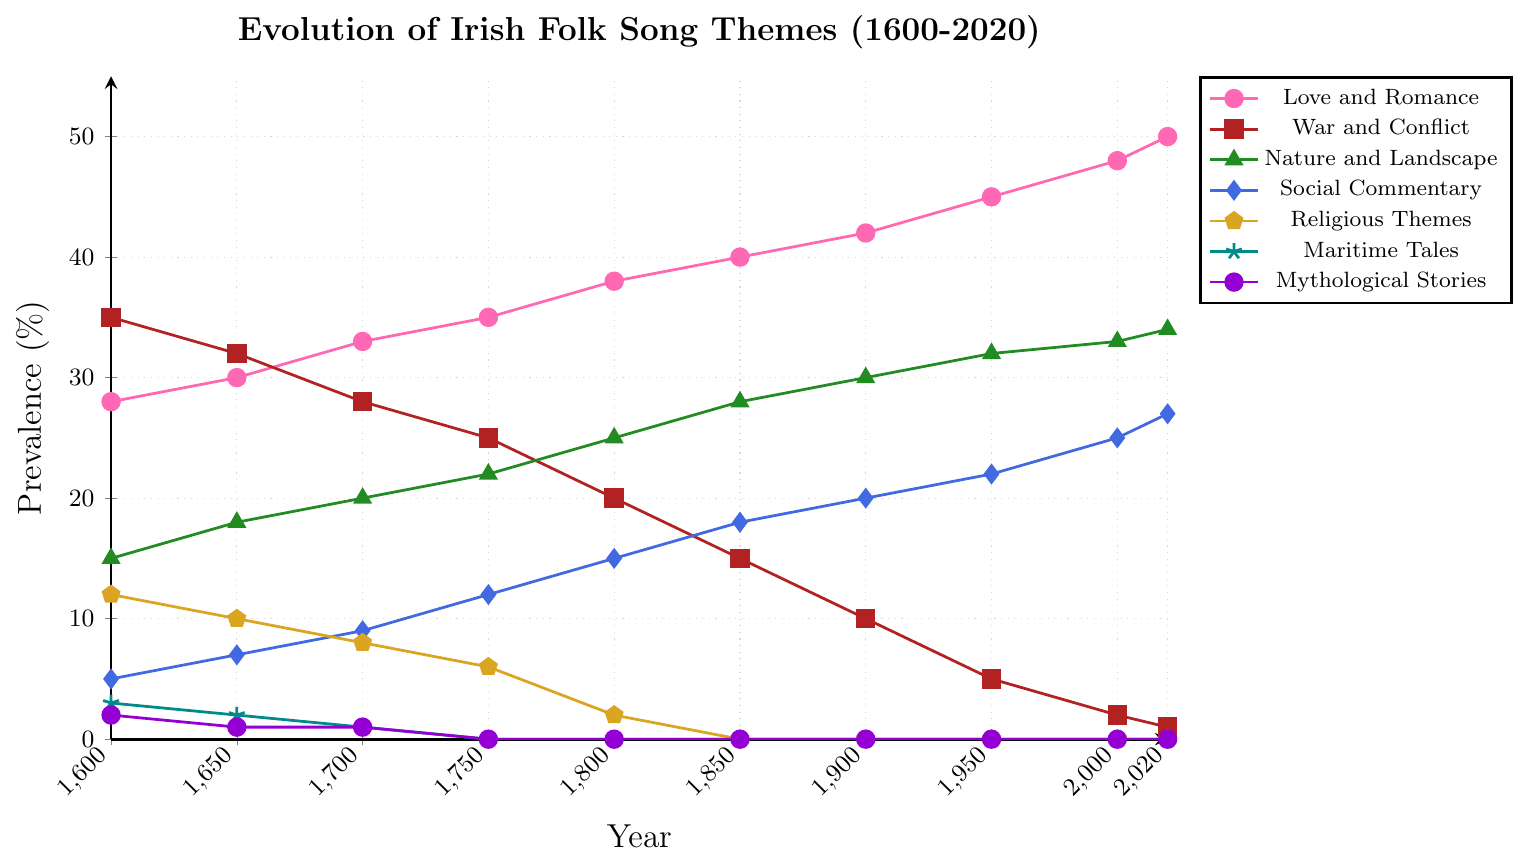What's the trend of the theme "Love and Romance" over the centuries? Starting from the year 1600 to 2020, observe the values plotted for "Love and Romance". The prevalence starts at 28% in 1600 and increases steadily to 50% in 2020.
Answer: It shows a steady increase Which theme saw the greatest decline from 1600 to 2020? To determine this, compare the values for each theme at the start and end years. "War and Conflict" starts at 35% in 1600 and declines to 1% in 2020, which is the largest drop.
Answer: War and Conflict How does the prevalence of "Nature and Landscape" in 2000 compare to 2020? Look at the values for "Nature and Landscape" for 2000 and 2020. The prevalence is 33% in 2000 and increases slightly to 34% in 2020.
Answer: It increased What's the difference in prevalence between "Social Commentary" and "Religious Themes" in 1800? From the figure, the prevalence of "Social Commentary" in 1800 is 15% and "Religious Themes" is 2%. Subtract 2 from 15 to find the difference.
Answer: 13% What year had an equal prevalence for "Love and Romance" and "Nature and Landscape"? Find where the values for both themes meet. In 1700, both "Love and Romance" and "Nature and Landscape" have a prevalence of 20%.
Answer: 1700 What is the average prevalence of "Mythological Stories" over the centuries displayed in the chart? The values are 2, 1, 1, 0, 0, 0, 0, 0, 0, and 0. Sum them up (2+1+1+0+0+0+0+0+0+0=4) and divide by the number of points (10).
Answer: 0.4% Which theme has the highest prevalence in 1650? Locate the values for each theme in 1650 and identify the highest one. "War and Conflict" has the highest prevalence at 32%.
Answer: War and Conflict How many themes never reach a prevalence above 5% throughout the years shown? Review each line in the graph and note if any theme has all values below or equal to 5%. "Maritime Tales" and "Mythological Stories" fit this description.
Answer: Two themes If you sum the prevalence of "War and Conflict" and "Maritime Tales" in 1750, what do you get? The prevalence for "War and Conflict" in 1750 is 25% and for "Maritime Tales" it is 0%. Adding these together gives 25%.
Answer: 25% Which theme's prevalence remains constant from 2000 to 2020? Compare the prevalence values between 2000 and 2020 for each theme and see if any remain unchanged. "Religious Themes," "Maritime Tales," and "Mythological Stories" all stay constant at 0%.
Answer: Religious Themes, Maritime Tales, Mythological Stories 